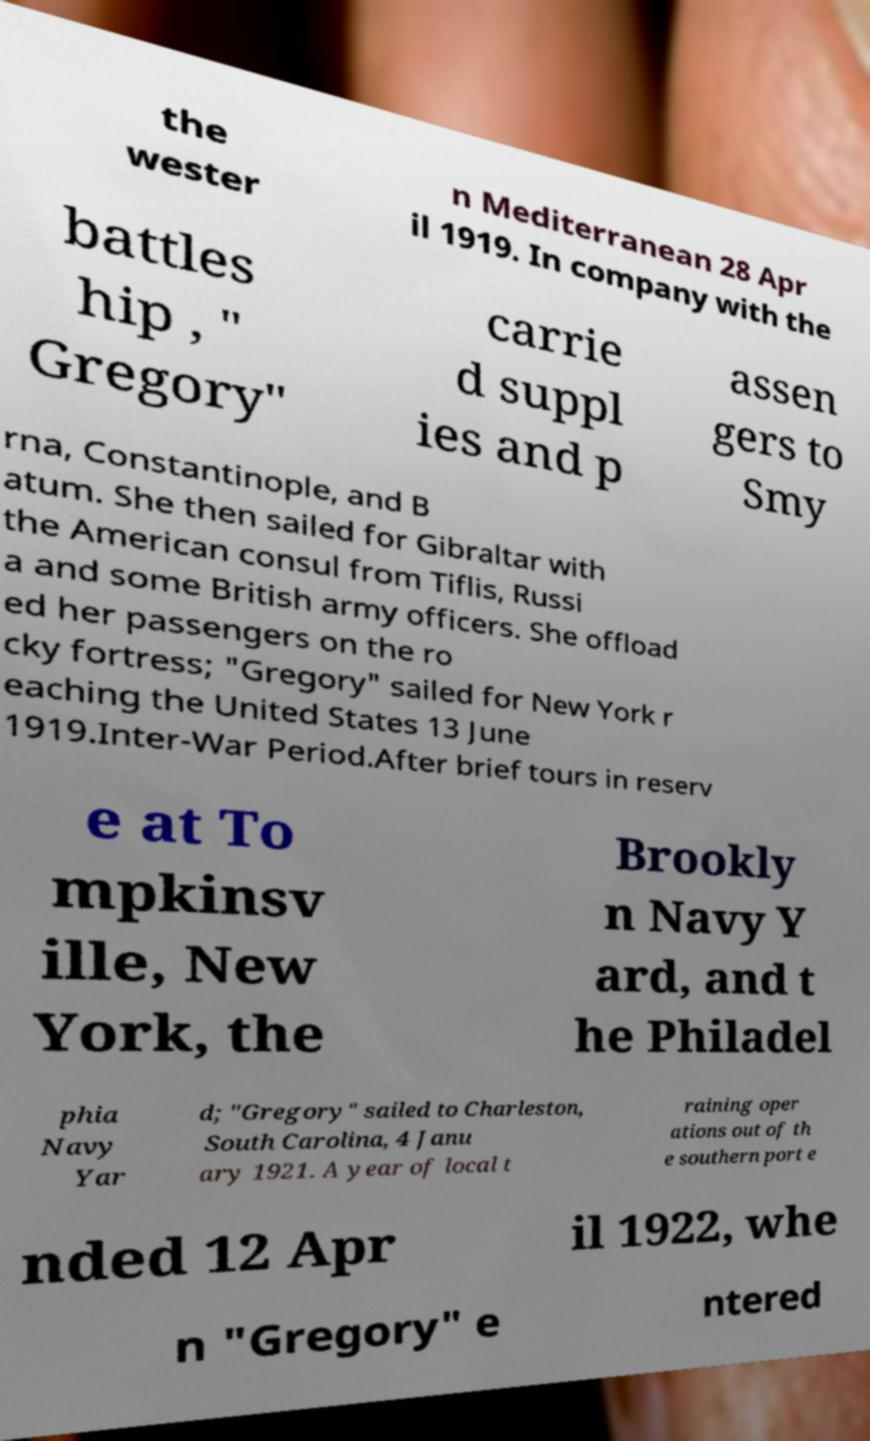Could you extract and type out the text from this image? the wester n Mediterranean 28 Apr il 1919. In company with the battles hip , " Gregory" carrie d suppl ies and p assen gers to Smy rna, Constantinople, and B atum. She then sailed for Gibraltar with the American consul from Tiflis, Russi a and some British army officers. She offload ed her passengers on the ro cky fortress; "Gregory" sailed for New York r eaching the United States 13 June 1919.Inter-War Period.After brief tours in reserv e at To mpkinsv ille, New York, the Brookly n Navy Y ard, and t he Philadel phia Navy Yar d; "Gregory" sailed to Charleston, South Carolina, 4 Janu ary 1921. A year of local t raining oper ations out of th e southern port e nded 12 Apr il 1922, whe n "Gregory" e ntered 